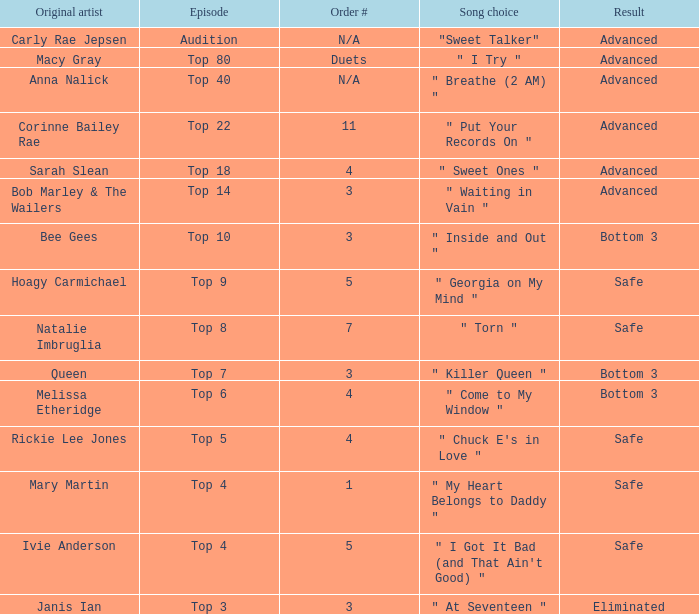What's the total number of songs originally performed by Anna Nalick? 1.0. 